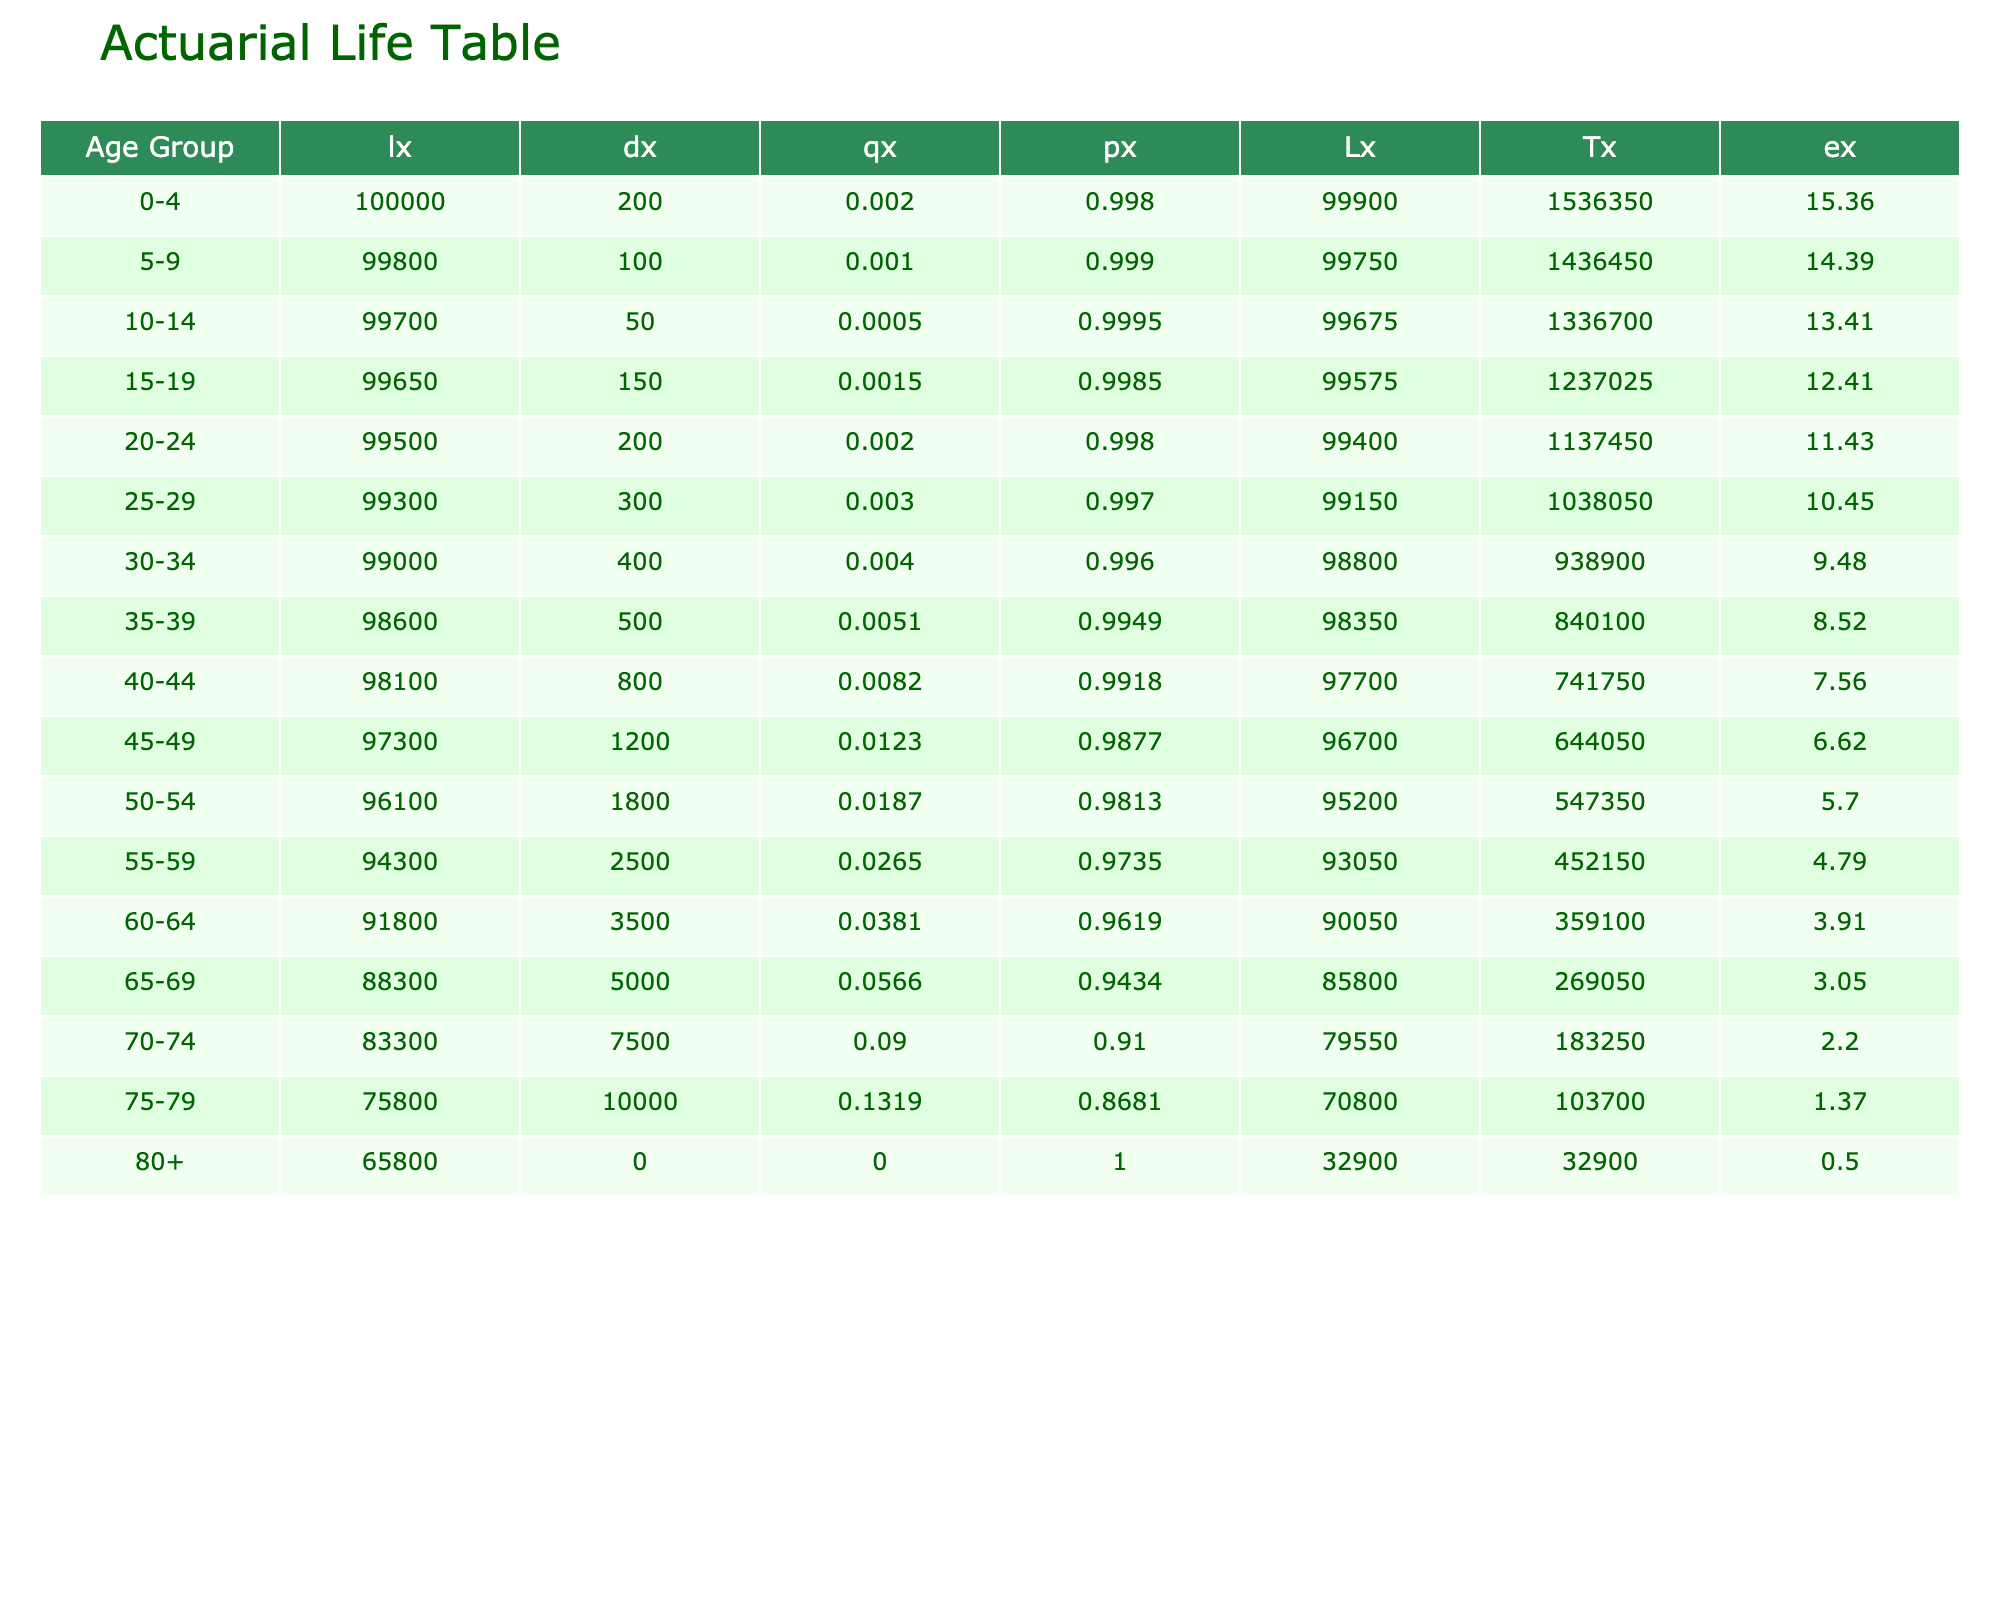What is the mortality rate for the age group 60-64? The table clearly lists the mortality rates for each age group, and for the age group 60-64, the corresponding mortality rate is 0.035.
Answer: 0.035 What is the population of the age group 75-79? From the table, the population for each age group is consistently listed as 100,000. Therefore, the population for the age group 75-79 is also 100,000.
Answer: 100,000 How many deaths occurred in the age group 50-54? The age group 50-54 shows that the number of deaths is listed as 1,800 in the table.
Answer: 1,800 What is the average mortality rate for age groups 0-4 and 5-9? To find the average, add the mortality rates for these two groups, which are 0.002 and 0.001. The sum is 0.002 + 0.001 = 0.003. Then divide by the number of groups, which is 2: 0.003 / 2 = 0.0015.
Answer: 0.0015 Is the mortality rate highest for the age group 80+ among the listed groups? Looking at the table, the mortality rate for the age group 80+ is 0.150, which is higher than all other age groups listed. Therefore, it is true that the mortality rate is highest for this age group.
Answer: Yes What is the total number of deaths recorded from age groups 65-69 and 70-74 combined? The number of deaths in age group 65-69 is 5,000, and for age group 70-74, it is 7,500. Combine these two figures: 5,000 + 7,500 = 12,500.
Answer: 12,500 If a person is in the age group 35-39, what is the probability that they will survive to the next age group (40-44)? The probability of surviving to the next age group (px) calculated for age group 35-39 is 1 - qx. First, find qx for age group 35-39, which is 0.005. Thus, px = 1 - 0.005 = 0.995, meaning there is a 99.5% chance of survival to the next age group.
Answer: 0.995 How many more deaths were there in the age group 75-79 compared to the age group 70-74? In the table, the number of deaths in age group 75-79 is 10,000, while for age group 70-74 it is 7,500. To find the difference, subtract: 10,000 - 7,500 = 2,500.
Answer: 2,500 What is the death rate increase from the age group 70-74 to 75-79? The death rate for 70-74 is recorded as 0.075 and for 75-79 it is 0.100. To calculate the increase, subtract the earlier rate from the later rate: 0.100 - 0.075 = 0.025.
Answer: 0.025 